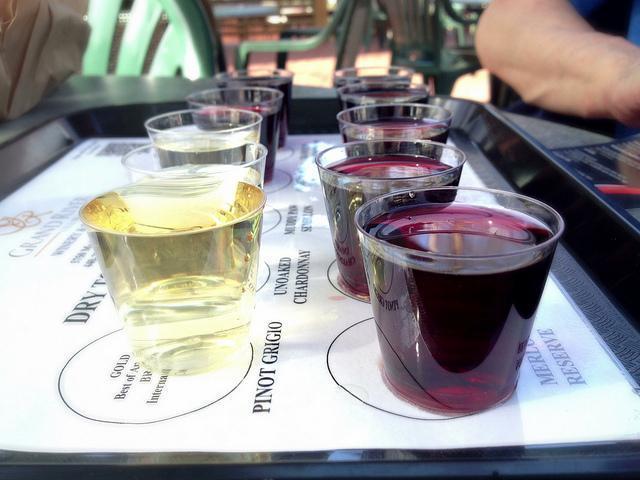How many dining tables are in the picture?
Give a very brief answer. 2. How many cups can be seen?
Give a very brief answer. 8. How many chairs can be seen?
Give a very brief answer. 3. 